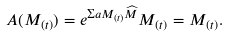<formula> <loc_0><loc_0><loc_500><loc_500>A ( M _ { ( t ) } ) = e ^ { \Sigma a M _ { ( t ) } \widehat { M } } M _ { ( t ) } = M _ { ( t ) } .</formula> 